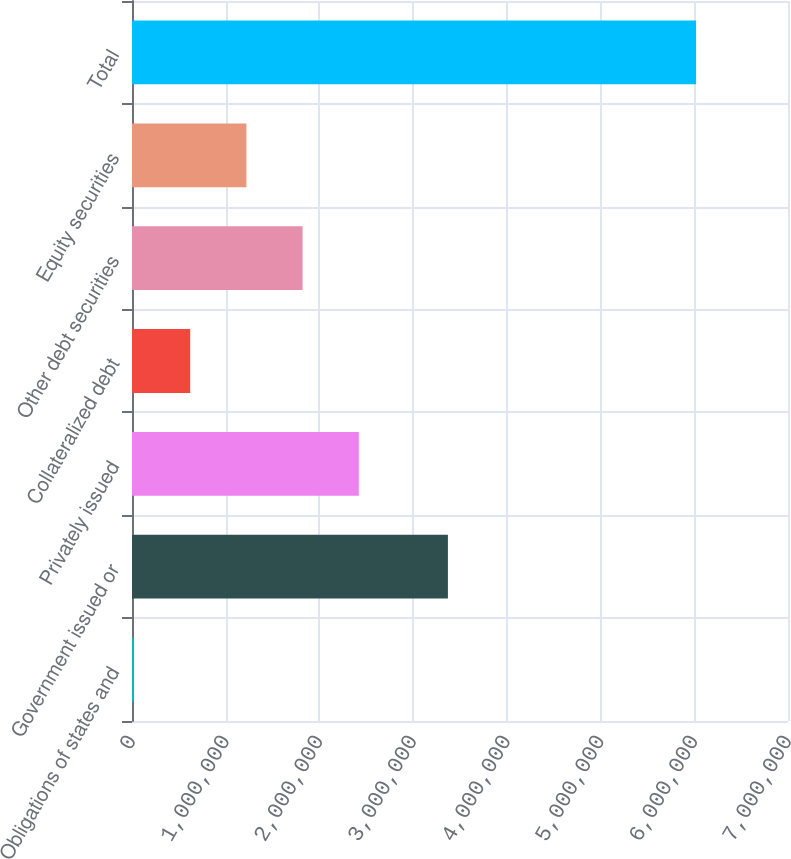Convert chart to OTSL. <chart><loc_0><loc_0><loc_500><loc_500><bar_chart><fcel>Obligations of states and<fcel>Government issued or<fcel>Privately issued<fcel>Collateralized debt<fcel>Other debt securities<fcel>Equity securities<fcel>Total<nl><fcel>20901<fcel>3.37104e+06<fcel>2.42013e+06<fcel>620708<fcel>1.82032e+06<fcel>1.22051e+06<fcel>6.01897e+06<nl></chart> 